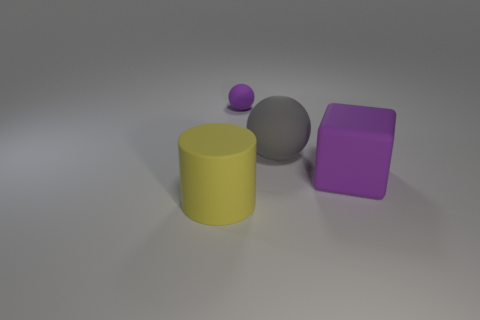Add 1 big matte blocks. How many objects exist? 5 Subtract all cylinders. How many objects are left? 3 Subtract all big blue balls. Subtract all large matte blocks. How many objects are left? 3 Add 1 purple things. How many purple things are left? 3 Add 4 small things. How many small things exist? 5 Subtract 0 yellow cubes. How many objects are left? 4 